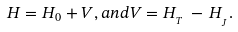<formula> <loc_0><loc_0><loc_500><loc_500>H = H _ { 0 } + V , a n d V = H _ { _ { T } } \, - \, H _ { _ { _ { J } } } .</formula> 